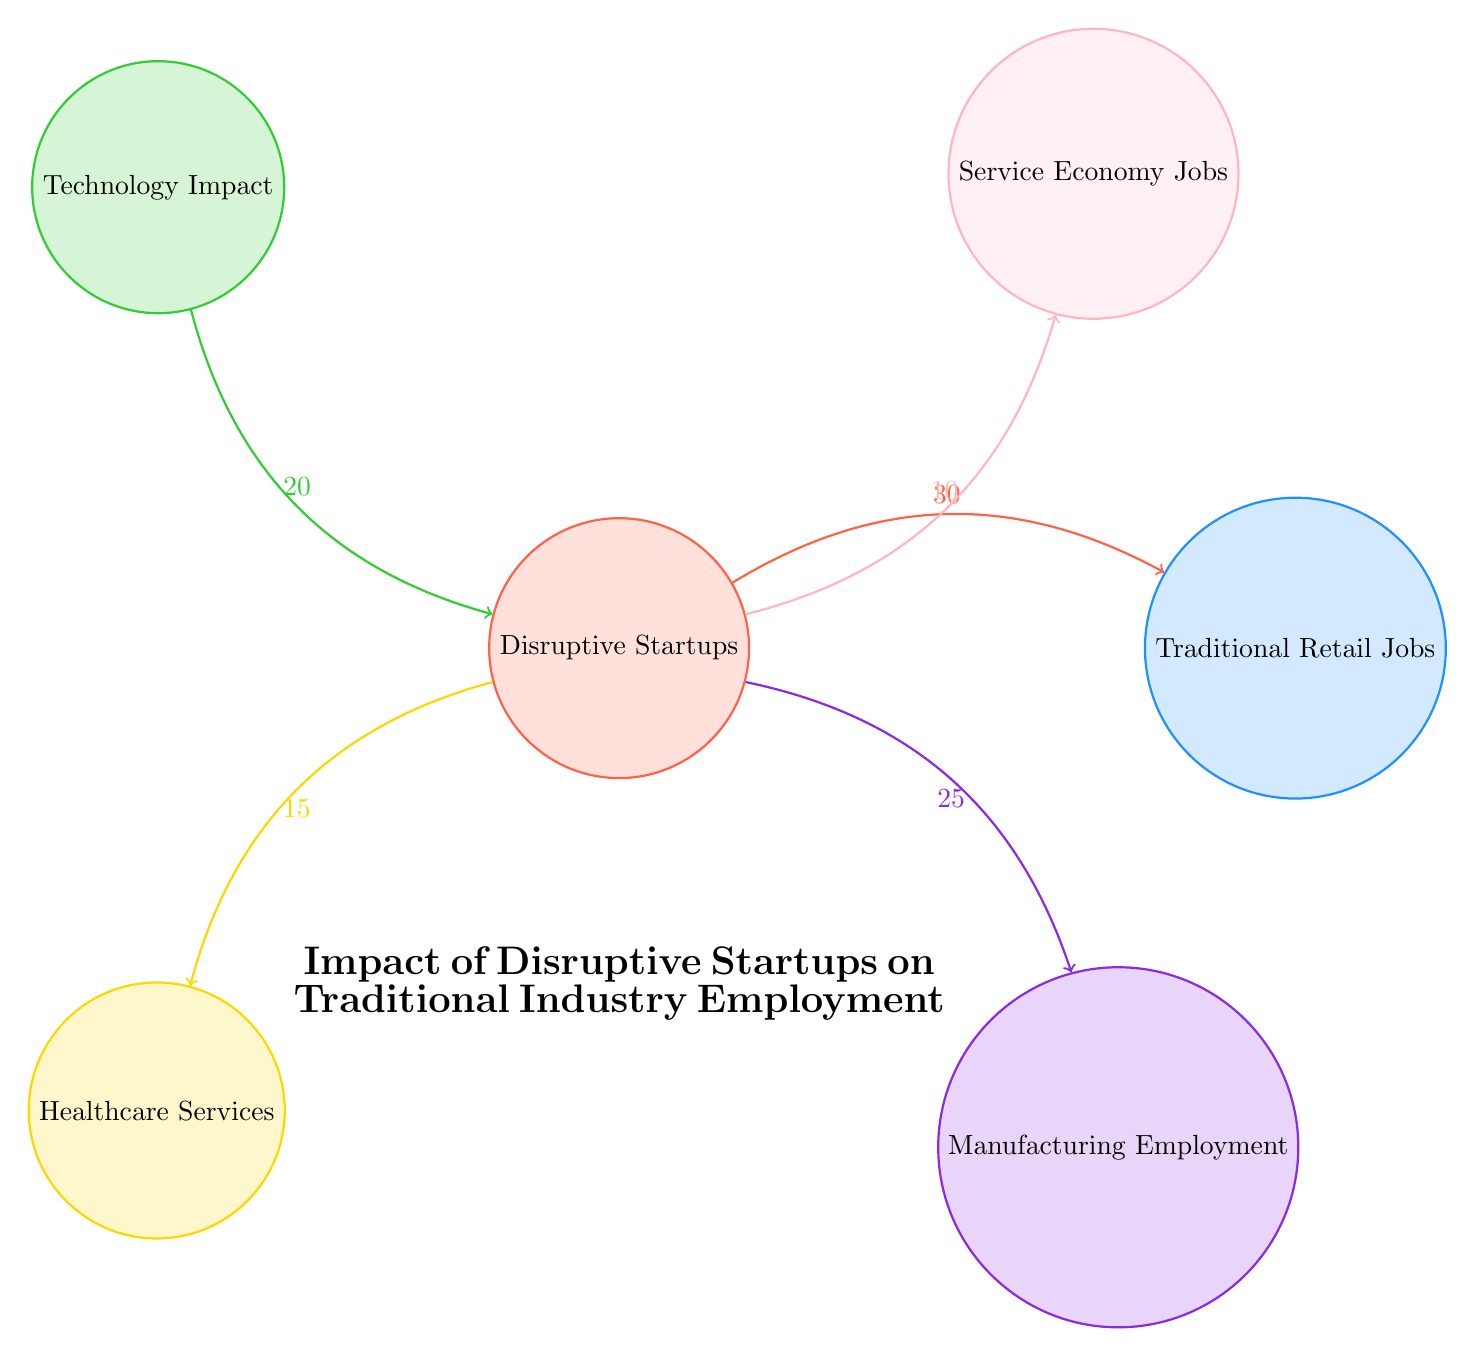What is the value connecting Disruptive Startups to Traditional Retail Jobs? The diagram indicates a direct connection from "Disruptive Startups" to "Traditional Retail Jobs" with a value of 30. This value represents the impact or effect of disruptive startups on traditional retail jobs.
Answer: 30 How many nodes are present in the diagram? The diagram contains six nodes: Disruptive Startups, Traditional Retail Jobs, Technology Impact, Healthcare Services, Manufacturing Employment, and Service Economy Jobs. Counting these gives us a total of six nodes.
Answer: 6 Which node has the highest impact value from Disruptive Startups? Examining the links, the highest impact value emanating from "Disruptive Startups" is towards "Traditional Retail Jobs" with a value of 30. This identifies it as having the most significant connection in the diagram.
Answer: Traditional Retail Jobs What impact value connects Disruptive Startups to Healthcare Services? The diagram shows a direct link from "Disruptive Startups" to "Healthcare Services" with a value of 15. This identifies the level of influence that startups have on healthcare services.
Answer: 15 Which node has the least connection value to Disruptive Startups? By analyzing the connections, "Service Economy Jobs" has the least connection value from "Disruptive Startups" at 10. This indicates it has the smallest impact among the connections illustrated.
Answer: Service Economy Jobs What are the total outgoing values from Disruptive Startups? To find the total outgoing values from "Disruptive Startups", sum the values on the outgoing links: 30 (Retail) + 15 (Healthcare) + 25 (Manufacturing) + 10 (Service) = 80. Therefore, the total is 80.
Answer: 80 Which two nodes are directly connected by the link representing 25? The value of 25 represents the connection between "Disruptive Startups" and "Manufacturing Employment". This identifies the specific links that influence the manufacturing sector directly.
Answer: Manufacturing Employment How many nodes directly connect to Disruptive Startups? After assessing the diagram, there are four nodes with direct connections to "Disruptive Startups": "Traditional Retail Jobs", "Healthcare Services", "Manufacturing Employment", and "Service Economy Jobs". Thus, it shows four directions of impact.
Answer: 4 